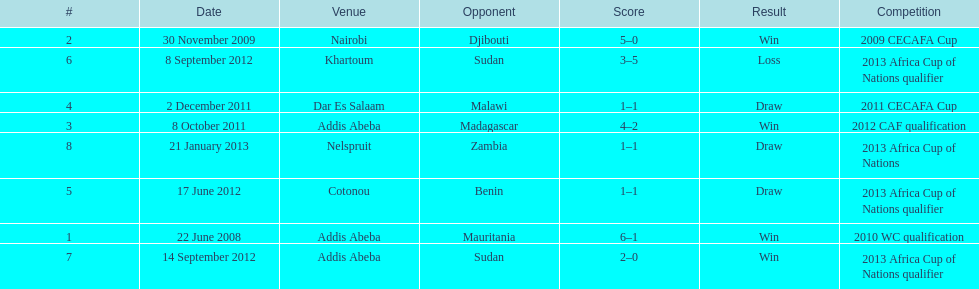For each winning game, what was their score? 6-1, 5-0, 4-2, 2-0. 